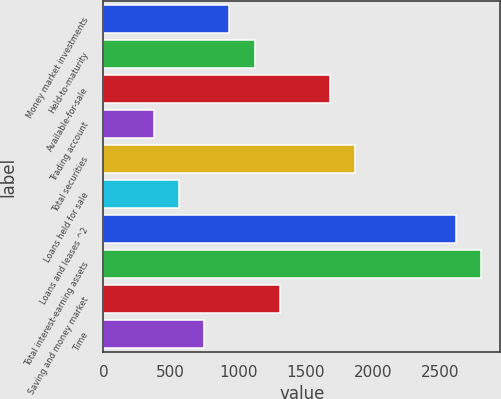Convert chart to OTSL. <chart><loc_0><loc_0><loc_500><loc_500><bar_chart><fcel>Money market investments<fcel>Held-to-maturity<fcel>Available-for-sale<fcel>Trading account<fcel>Total securities<fcel>Loans held for sale<fcel>Loans and leases ^2<fcel>Total interest-earning assets<fcel>Saving and money market<fcel>Time<nl><fcel>934.7<fcel>1121.58<fcel>1682.22<fcel>374.06<fcel>1869.1<fcel>560.94<fcel>2616.62<fcel>2803.5<fcel>1308.46<fcel>747.82<nl></chart> 